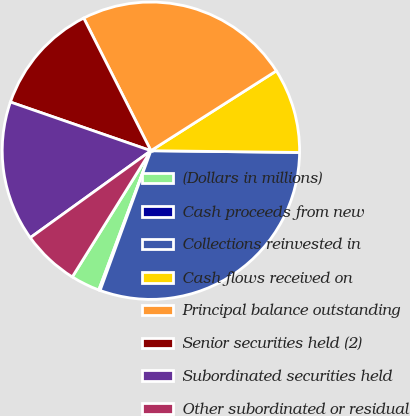<chart> <loc_0><loc_0><loc_500><loc_500><pie_chart><fcel>(Dollars in millions)<fcel>Cash proceeds from new<fcel>Collections reinvested in<fcel>Cash flows received on<fcel>Principal balance outstanding<fcel>Senior securities held (2)<fcel>Subordinated securities held<fcel>Other subordinated or residual<nl><fcel>3.17%<fcel>0.15%<fcel>30.36%<fcel>9.21%<fcel>23.44%<fcel>12.23%<fcel>15.25%<fcel>6.19%<nl></chart> 